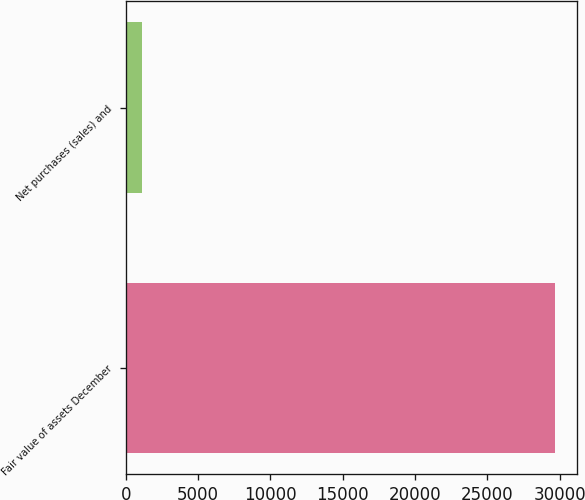Convert chart. <chart><loc_0><loc_0><loc_500><loc_500><bar_chart><fcel>Fair value of assets December<fcel>Net purchases (sales) and<nl><fcel>29697<fcel>1126<nl></chart> 